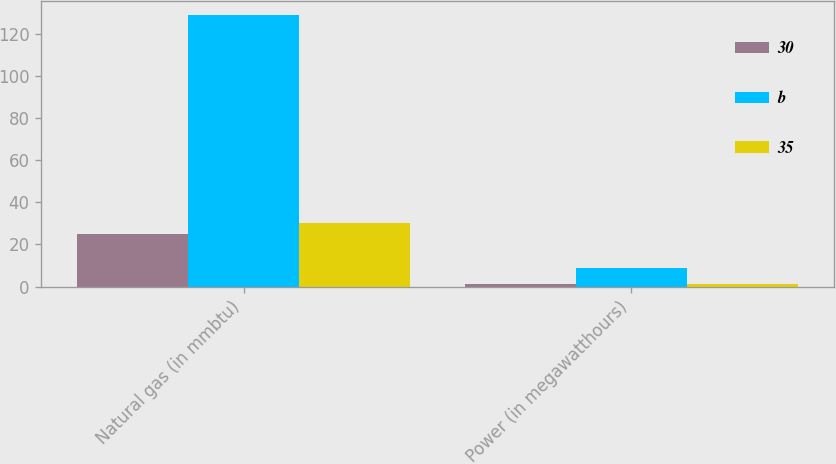Convert chart to OTSL. <chart><loc_0><loc_0><loc_500><loc_500><stacked_bar_chart><ecel><fcel>Natural gas (in mmbtu)<fcel>Power (in megawatthours)<nl><fcel>30<fcel>25<fcel>1<nl><fcel>b<fcel>129<fcel>9<nl><fcel>35<fcel>30<fcel>1<nl></chart> 